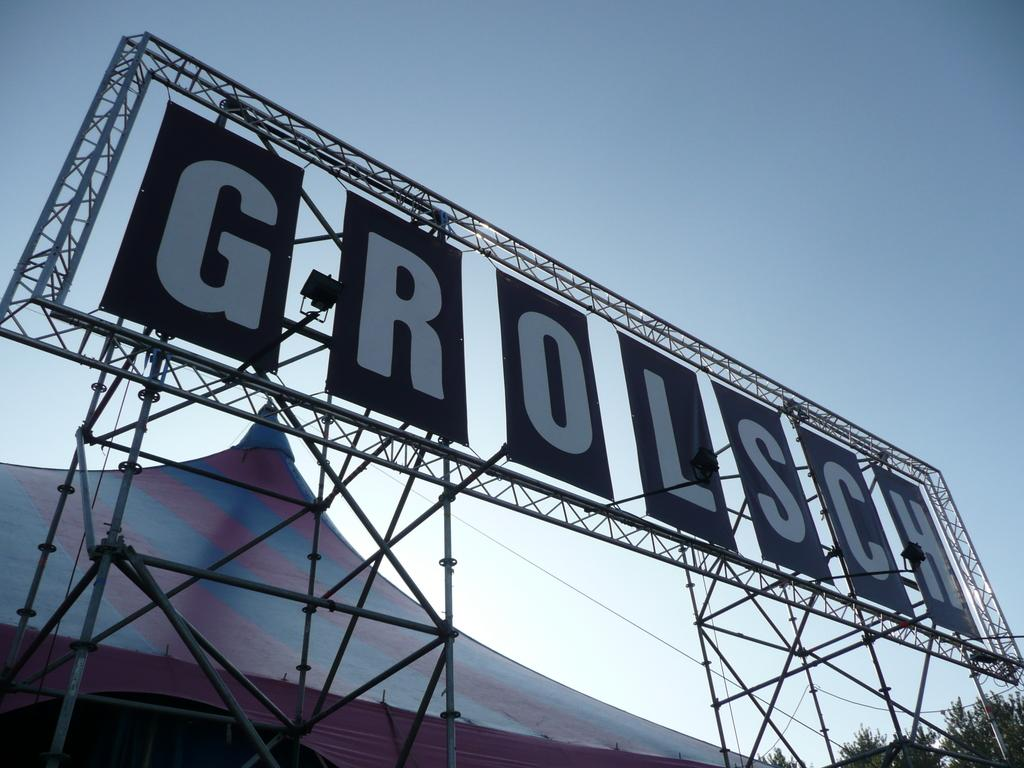<image>
Give a short and clear explanation of the subsequent image. the word Grolsch is on a large sign 